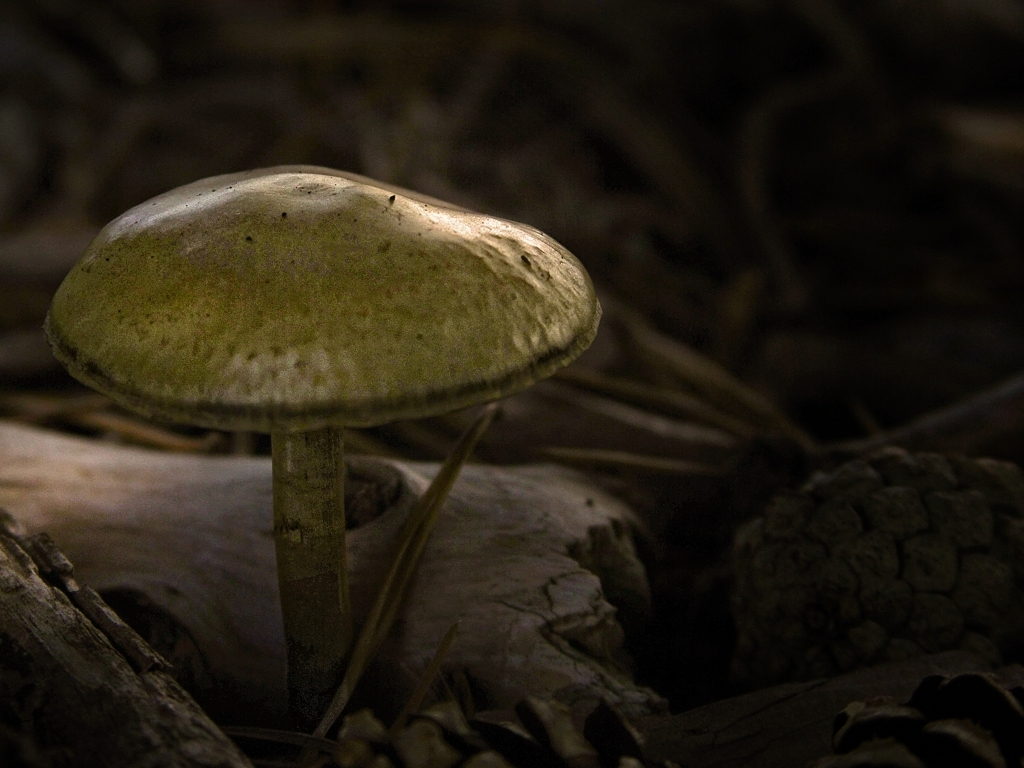What time of day does this photo seem to be taken? Given the soft, diffused lighting and the deep shadows present, it's likely that this photo was taken during the early morning or late afternoon, when the sun is at a lower angle. 